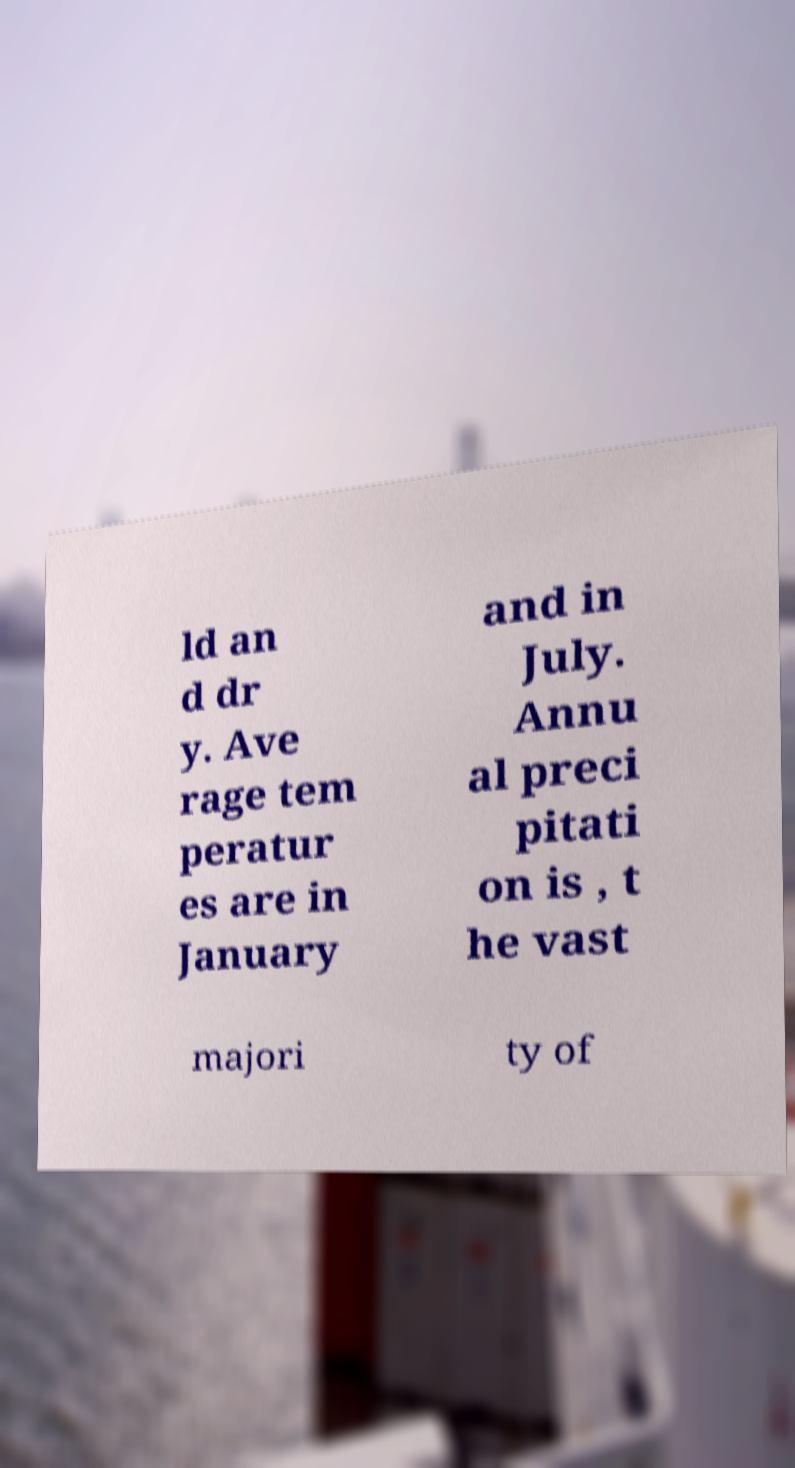For documentation purposes, I need the text within this image transcribed. Could you provide that? ld an d dr y. Ave rage tem peratur es are in January and in July. Annu al preci pitati on is , t he vast majori ty of 